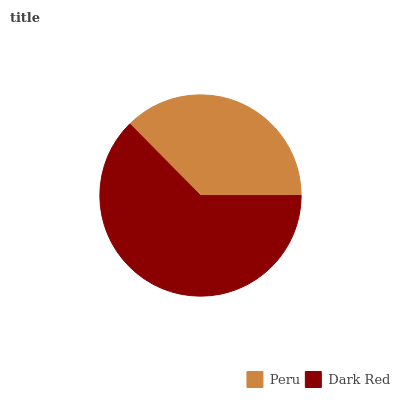Is Peru the minimum?
Answer yes or no. Yes. Is Dark Red the maximum?
Answer yes or no. Yes. Is Dark Red the minimum?
Answer yes or no. No. Is Dark Red greater than Peru?
Answer yes or no. Yes. Is Peru less than Dark Red?
Answer yes or no. Yes. Is Peru greater than Dark Red?
Answer yes or no. No. Is Dark Red less than Peru?
Answer yes or no. No. Is Dark Red the high median?
Answer yes or no. Yes. Is Peru the low median?
Answer yes or no. Yes. Is Peru the high median?
Answer yes or no. No. Is Dark Red the low median?
Answer yes or no. No. 